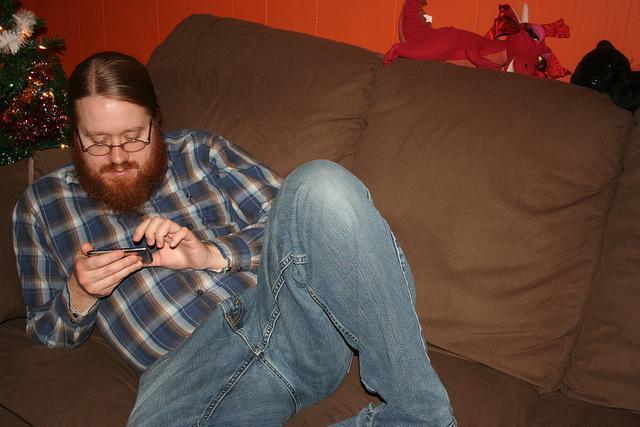What animal is the red stuffed animal?
Choose the correct response, then elucidate: 'Answer: answer
Rationale: rationale.'
Options: Dragon, giraffe, teddy bear, kitty. Answer: dragon.
Rationale: That is a dragon on the back of the couch. 